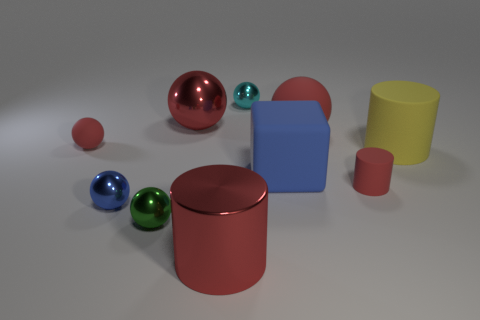There is a tiny red thing behind the big yellow matte cylinder; what is its material?
Offer a very short reply. Rubber. Are there any red matte things of the same size as the yellow rubber cylinder?
Provide a succinct answer. Yes. There is a big cylinder that is in front of the yellow thing; is it the same color as the large shiny ball?
Ensure brevity in your answer.  Yes. How many green objects are big balls or tiny matte cylinders?
Offer a very short reply. 0. How many things are the same color as the large rubber ball?
Provide a short and direct response. 4. Does the small green thing have the same material as the small blue object?
Keep it short and to the point. Yes. There is a tiny red object to the left of the tiny cyan object; what number of large shiny cylinders are to the right of it?
Offer a very short reply. 1. Does the green thing have the same size as the cyan sphere?
Offer a terse response. Yes. How many tiny cyan things have the same material as the green ball?
Provide a succinct answer. 1. The red metal object that is the same shape as the small blue object is what size?
Your response must be concise. Large. 